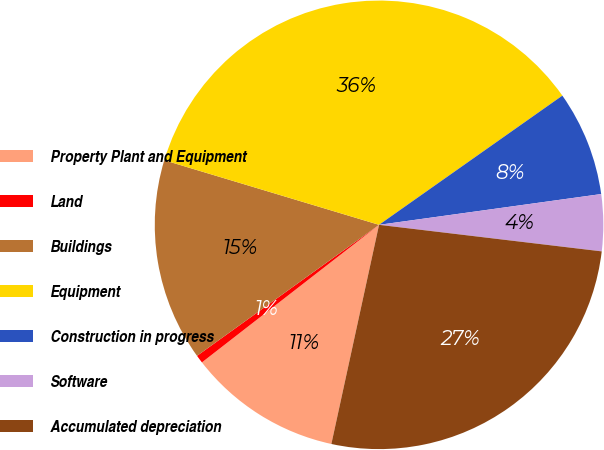<chart> <loc_0><loc_0><loc_500><loc_500><pie_chart><fcel>Property Plant and Equipment<fcel>Land<fcel>Buildings<fcel>Equipment<fcel>Construction in progress<fcel>Software<fcel>Accumulated depreciation<nl><fcel>11.08%<fcel>0.58%<fcel>14.58%<fcel>35.58%<fcel>7.58%<fcel>4.08%<fcel>26.52%<nl></chart> 